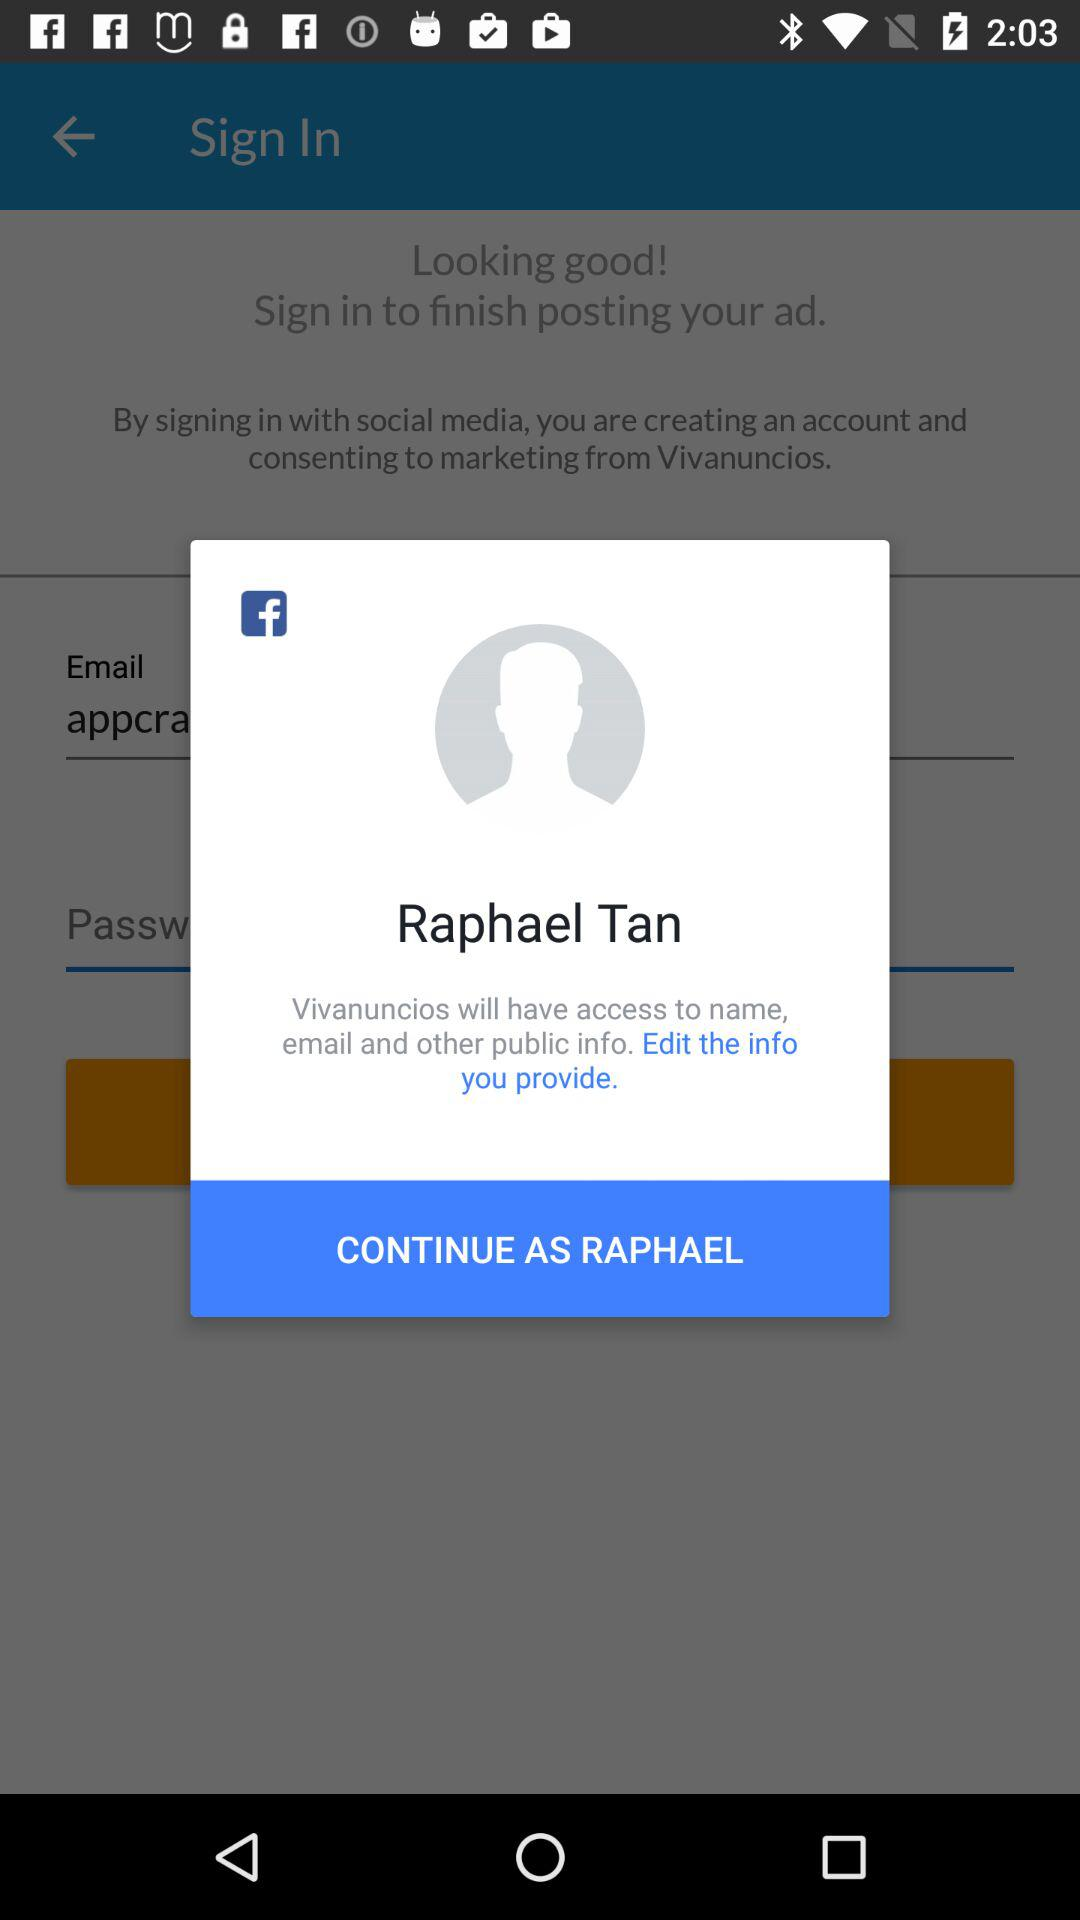What is the user's name? The user's name is Raphael Tan. 